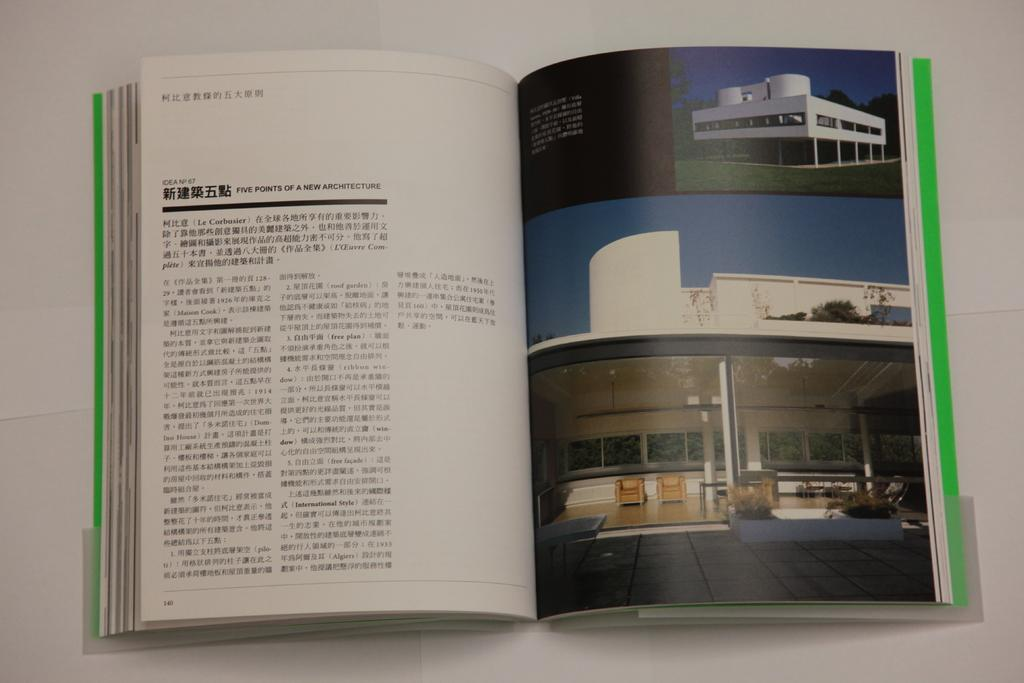<image>
Render a clear and concise summary of the photo. Booklet on a table that shows pictures of a home and five points of a new architecture 